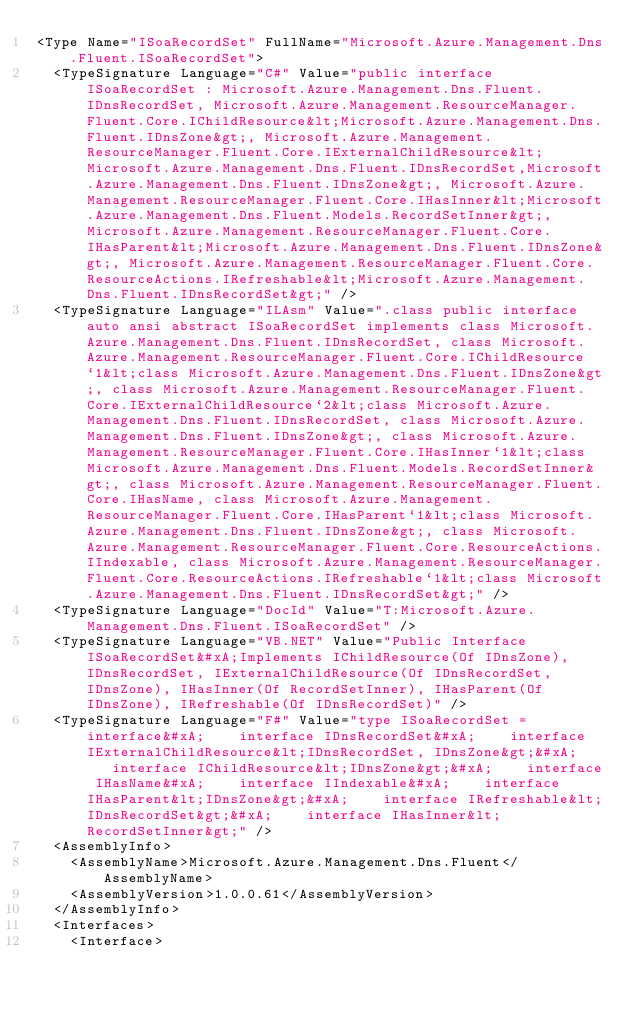Convert code to text. <code><loc_0><loc_0><loc_500><loc_500><_XML_><Type Name="ISoaRecordSet" FullName="Microsoft.Azure.Management.Dns.Fluent.ISoaRecordSet">
  <TypeSignature Language="C#" Value="public interface ISoaRecordSet : Microsoft.Azure.Management.Dns.Fluent.IDnsRecordSet, Microsoft.Azure.Management.ResourceManager.Fluent.Core.IChildResource&lt;Microsoft.Azure.Management.Dns.Fluent.IDnsZone&gt;, Microsoft.Azure.Management.ResourceManager.Fluent.Core.IExternalChildResource&lt;Microsoft.Azure.Management.Dns.Fluent.IDnsRecordSet,Microsoft.Azure.Management.Dns.Fluent.IDnsZone&gt;, Microsoft.Azure.Management.ResourceManager.Fluent.Core.IHasInner&lt;Microsoft.Azure.Management.Dns.Fluent.Models.RecordSetInner&gt;, Microsoft.Azure.Management.ResourceManager.Fluent.Core.IHasParent&lt;Microsoft.Azure.Management.Dns.Fluent.IDnsZone&gt;, Microsoft.Azure.Management.ResourceManager.Fluent.Core.ResourceActions.IRefreshable&lt;Microsoft.Azure.Management.Dns.Fluent.IDnsRecordSet&gt;" />
  <TypeSignature Language="ILAsm" Value=".class public interface auto ansi abstract ISoaRecordSet implements class Microsoft.Azure.Management.Dns.Fluent.IDnsRecordSet, class Microsoft.Azure.Management.ResourceManager.Fluent.Core.IChildResource`1&lt;class Microsoft.Azure.Management.Dns.Fluent.IDnsZone&gt;, class Microsoft.Azure.Management.ResourceManager.Fluent.Core.IExternalChildResource`2&lt;class Microsoft.Azure.Management.Dns.Fluent.IDnsRecordSet, class Microsoft.Azure.Management.Dns.Fluent.IDnsZone&gt;, class Microsoft.Azure.Management.ResourceManager.Fluent.Core.IHasInner`1&lt;class Microsoft.Azure.Management.Dns.Fluent.Models.RecordSetInner&gt;, class Microsoft.Azure.Management.ResourceManager.Fluent.Core.IHasName, class Microsoft.Azure.Management.ResourceManager.Fluent.Core.IHasParent`1&lt;class Microsoft.Azure.Management.Dns.Fluent.IDnsZone&gt;, class Microsoft.Azure.Management.ResourceManager.Fluent.Core.ResourceActions.IIndexable, class Microsoft.Azure.Management.ResourceManager.Fluent.Core.ResourceActions.IRefreshable`1&lt;class Microsoft.Azure.Management.Dns.Fluent.IDnsRecordSet&gt;" />
  <TypeSignature Language="DocId" Value="T:Microsoft.Azure.Management.Dns.Fluent.ISoaRecordSet" />
  <TypeSignature Language="VB.NET" Value="Public Interface ISoaRecordSet&#xA;Implements IChildResource(Of IDnsZone), IDnsRecordSet, IExternalChildResource(Of IDnsRecordSet, IDnsZone), IHasInner(Of RecordSetInner), IHasParent(Of IDnsZone), IRefreshable(Of IDnsRecordSet)" />
  <TypeSignature Language="F#" Value="type ISoaRecordSet = interface&#xA;    interface IDnsRecordSet&#xA;    interface IExternalChildResource&lt;IDnsRecordSet, IDnsZone&gt;&#xA;    interface IChildResource&lt;IDnsZone&gt;&#xA;    interface IHasName&#xA;    interface IIndexable&#xA;    interface IHasParent&lt;IDnsZone&gt;&#xA;    interface IRefreshable&lt;IDnsRecordSet&gt;&#xA;    interface IHasInner&lt;RecordSetInner&gt;" />
  <AssemblyInfo>
    <AssemblyName>Microsoft.Azure.Management.Dns.Fluent</AssemblyName>
    <AssemblyVersion>1.0.0.61</AssemblyVersion>
  </AssemblyInfo>
  <Interfaces>
    <Interface></code> 